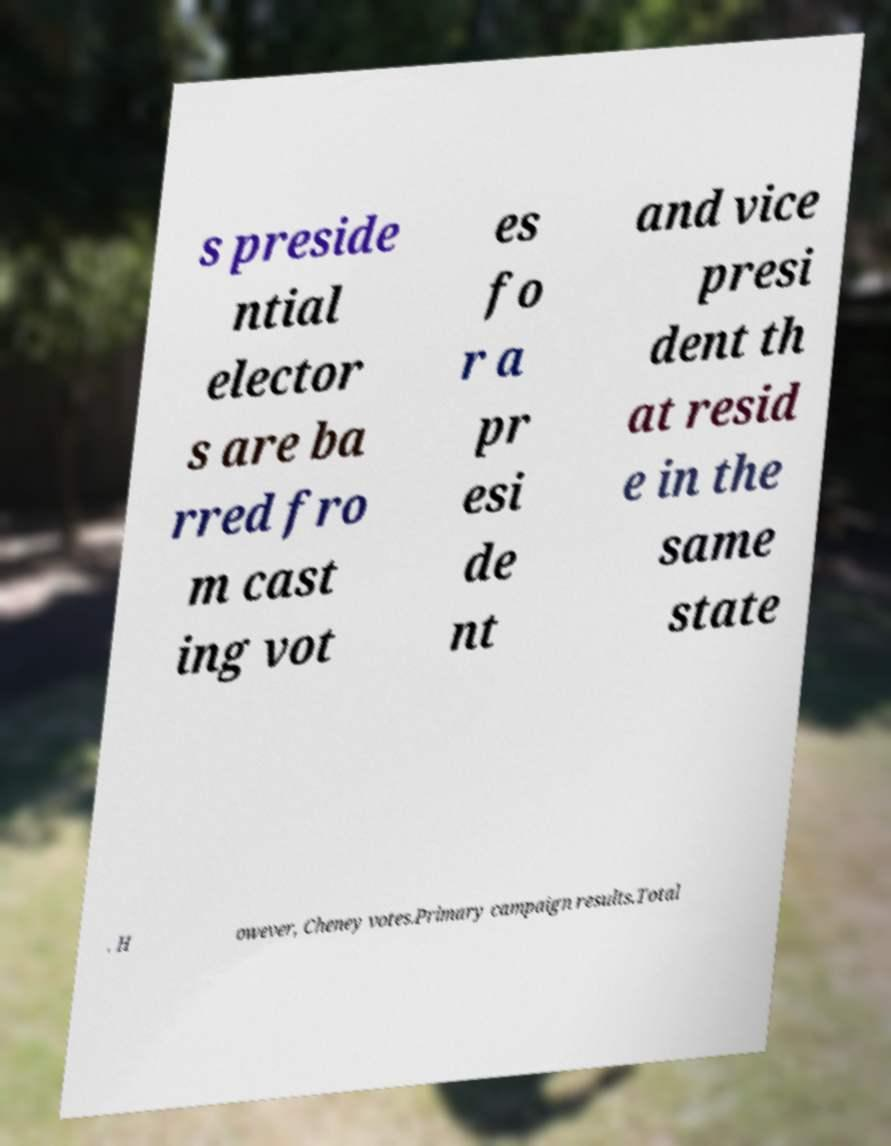What messages or text are displayed in this image? I need them in a readable, typed format. s preside ntial elector s are ba rred fro m cast ing vot es fo r a pr esi de nt and vice presi dent th at resid e in the same state . H owever, Cheney votes.Primary campaign results.Total 